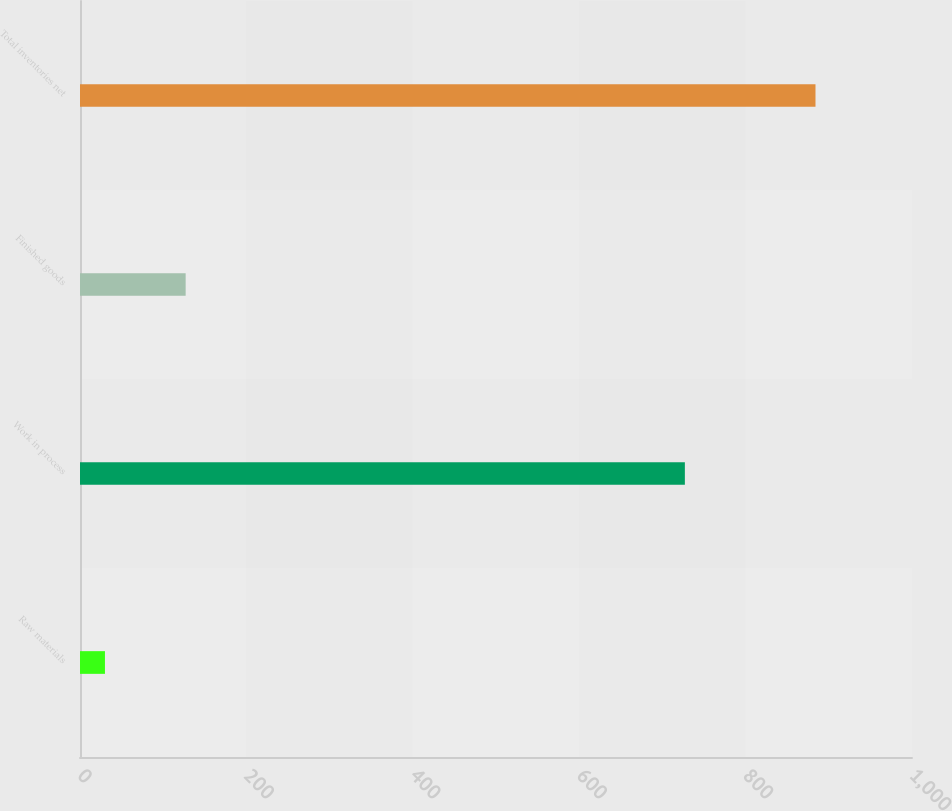Convert chart. <chart><loc_0><loc_0><loc_500><loc_500><bar_chart><fcel>Raw materials<fcel>Work in process<fcel>Finished goods<fcel>Total inventories net<nl><fcel>30<fcel>727<fcel>127<fcel>884<nl></chart> 